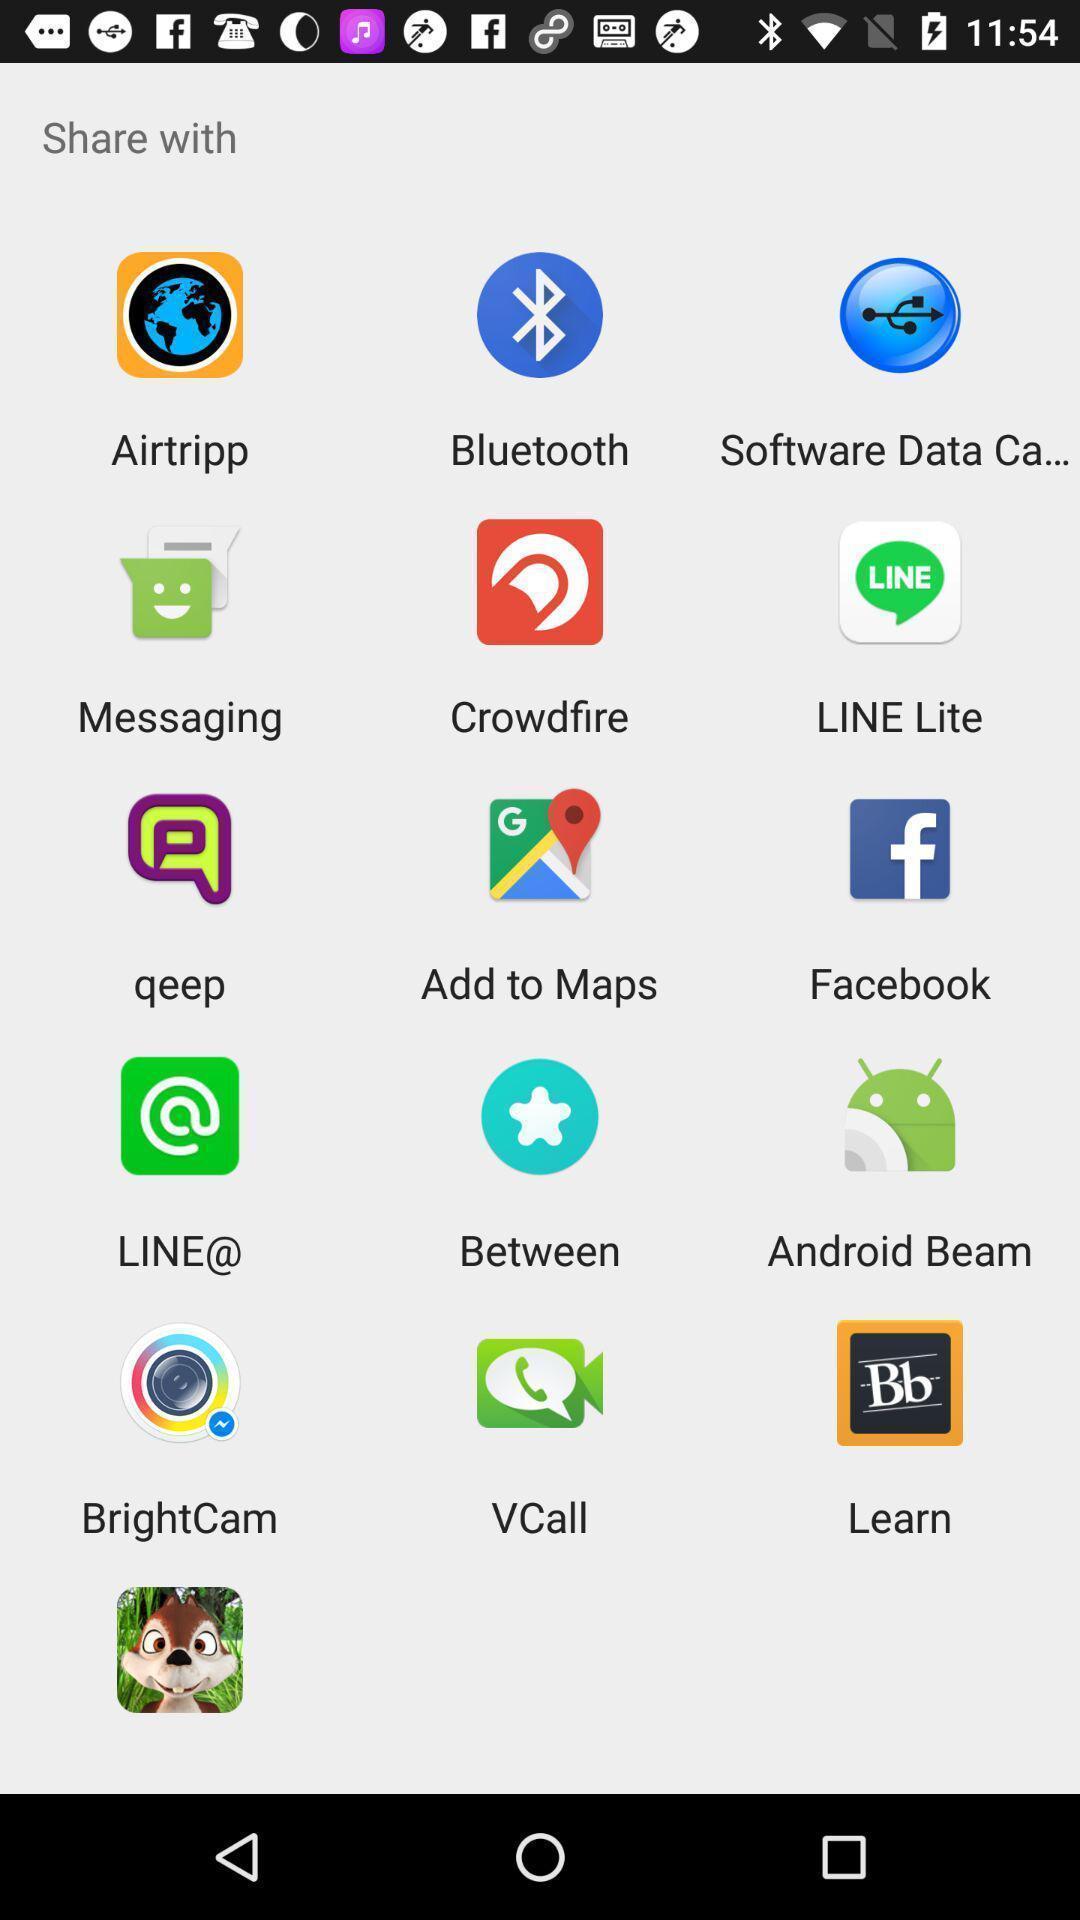Summarize the information in this screenshot. Screen shows share option with multiple applications. 